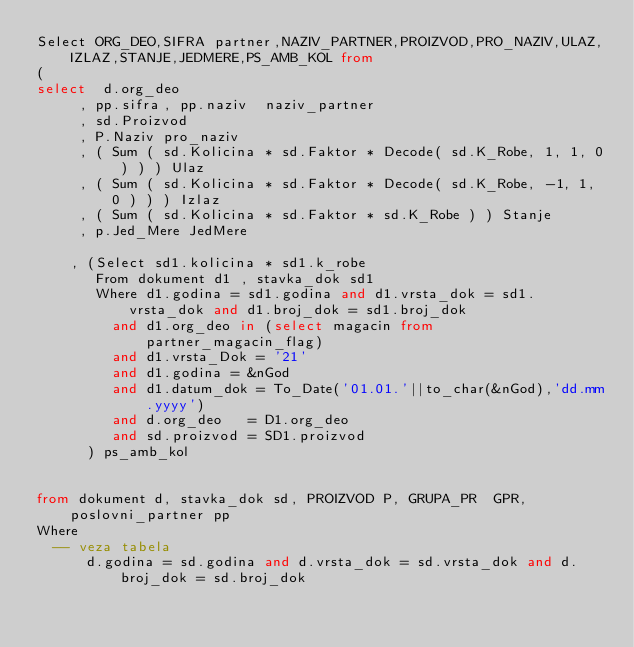<code> <loc_0><loc_0><loc_500><loc_500><_SQL_>Select ORG_DEO,SIFRA partner,NAZIV_PARTNER,PROIZVOD,PRO_NAZIV,ULAZ,IZLAZ,STANJE,JEDMERE,PS_AMB_KOL from
(
select  d.org_deo
     , pp.sifra, pp.naziv  naziv_partner
     , sd.Proizvod
     , P.Naziv pro_naziv
     , ( Sum ( sd.Kolicina * sd.Faktor * Decode( sd.K_Robe, 1, 1, 0 ) ) ) Ulaz
     , ( Sum ( sd.Kolicina * sd.Faktor * Decode( sd.K_Robe, -1, 1, 0 ) ) ) Izlaz
     , ( Sum ( sd.Kolicina * sd.Faktor * sd.K_Robe ) ) Stanje
     , p.Jed_Mere JedMere

    , (Select sd1.kolicina * sd1.k_robe
       From dokument d1 , stavka_dok sd1
       Where d1.godina = sd1.godina and d1.vrsta_dok = sd1.vrsta_dok and d1.broj_dok = sd1.broj_dok
         and d1.org_deo in (select magacin from partner_magacin_flag)
         and d1.vrsta_Dok = '21'
         and d1.godina = &nGod
         and d1.datum_dok = To_Date('01.01.'||to_char(&nGod),'dd.mm.yyyy')
         and d.org_deo   = D1.org_deo
         and sd.proizvod = SD1.proizvod
      ) ps_amb_kol


from dokument d, stavka_dok sd, PROIZVOD P, GRUPA_PR  GPR, poslovni_partner pp
Where
  -- veza tabela
      d.godina = sd.godina and d.vrsta_dok = sd.vrsta_dok and d.broj_dok = sd.broj_dok</code> 